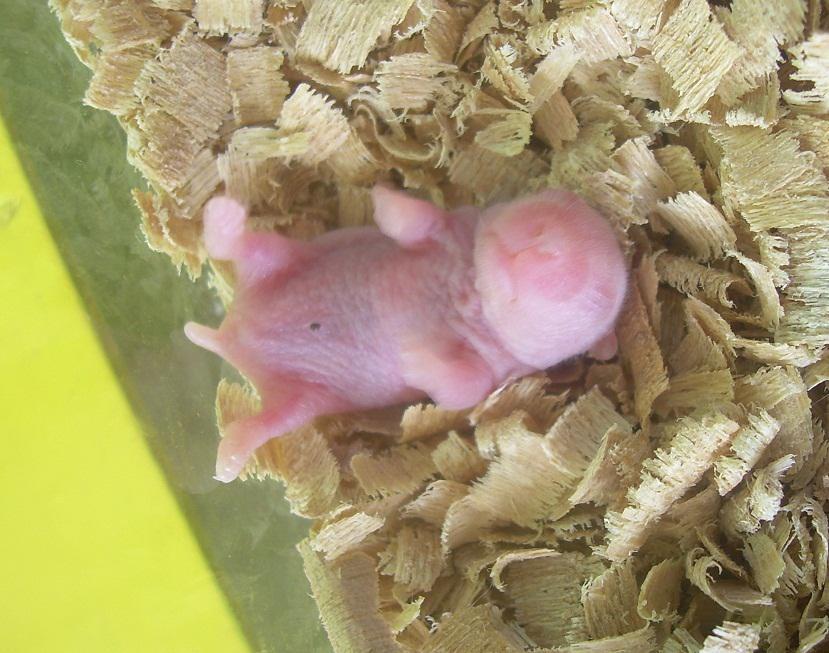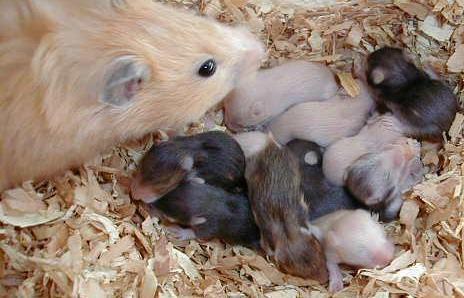The first image is the image on the left, the second image is the image on the right. Evaluate the accuracy of this statement regarding the images: "the image on the right contains a single animal". Is it true? Answer yes or no. No. The first image is the image on the left, the second image is the image on the right. For the images displayed, is the sentence "There are several hairless newborn hamsters in one of the images." factually correct? Answer yes or no. No. 